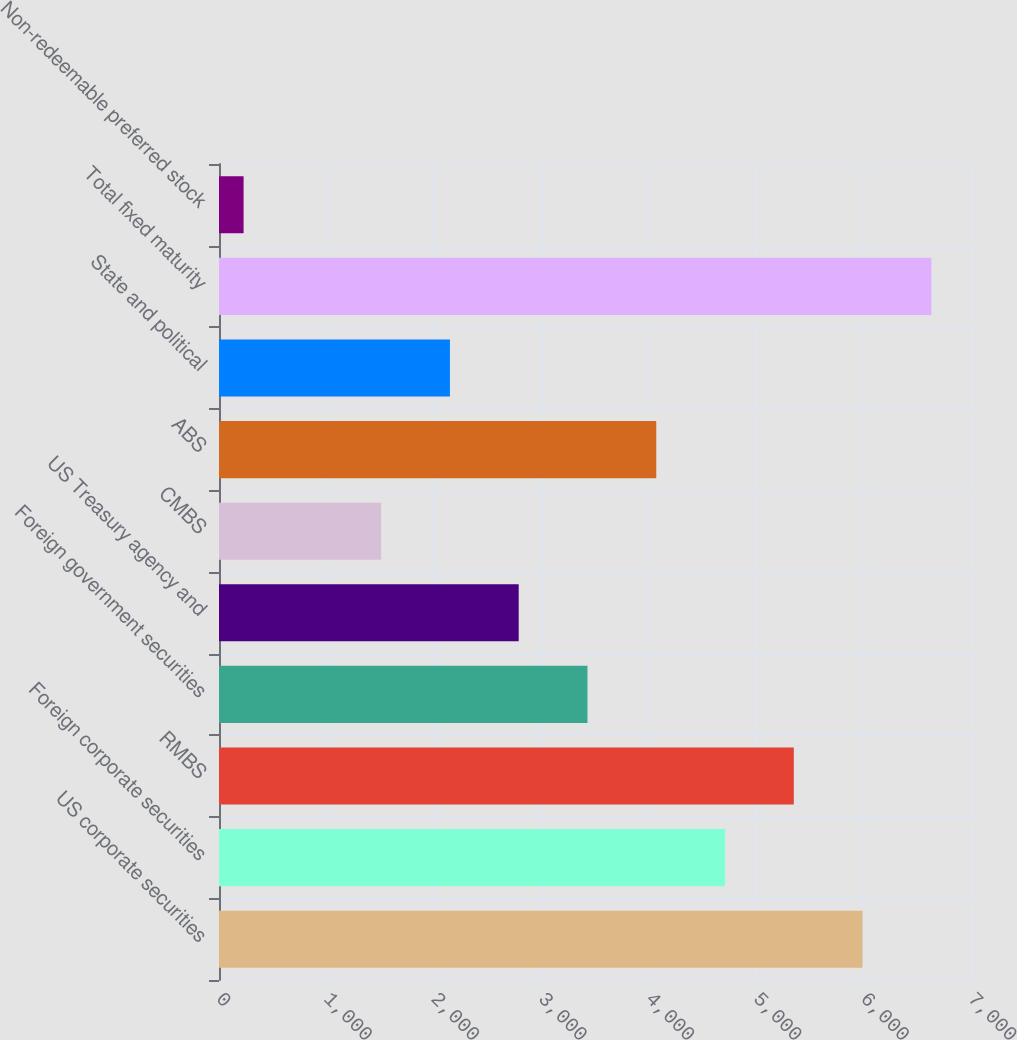Convert chart to OTSL. <chart><loc_0><loc_0><loc_500><loc_500><bar_chart><fcel>US corporate securities<fcel>Foreign corporate securities<fcel>RMBS<fcel>Foreign government securities<fcel>US Treasury agency and<fcel>CMBS<fcel>ABS<fcel>State and political<fcel>Total fixed maturity<fcel>Non-redeemable preferred stock<nl><fcel>5990.8<fcel>4710.4<fcel>5350.6<fcel>3430<fcel>2789.8<fcel>1509.4<fcel>4070.2<fcel>2149.6<fcel>6631<fcel>229<nl></chart> 